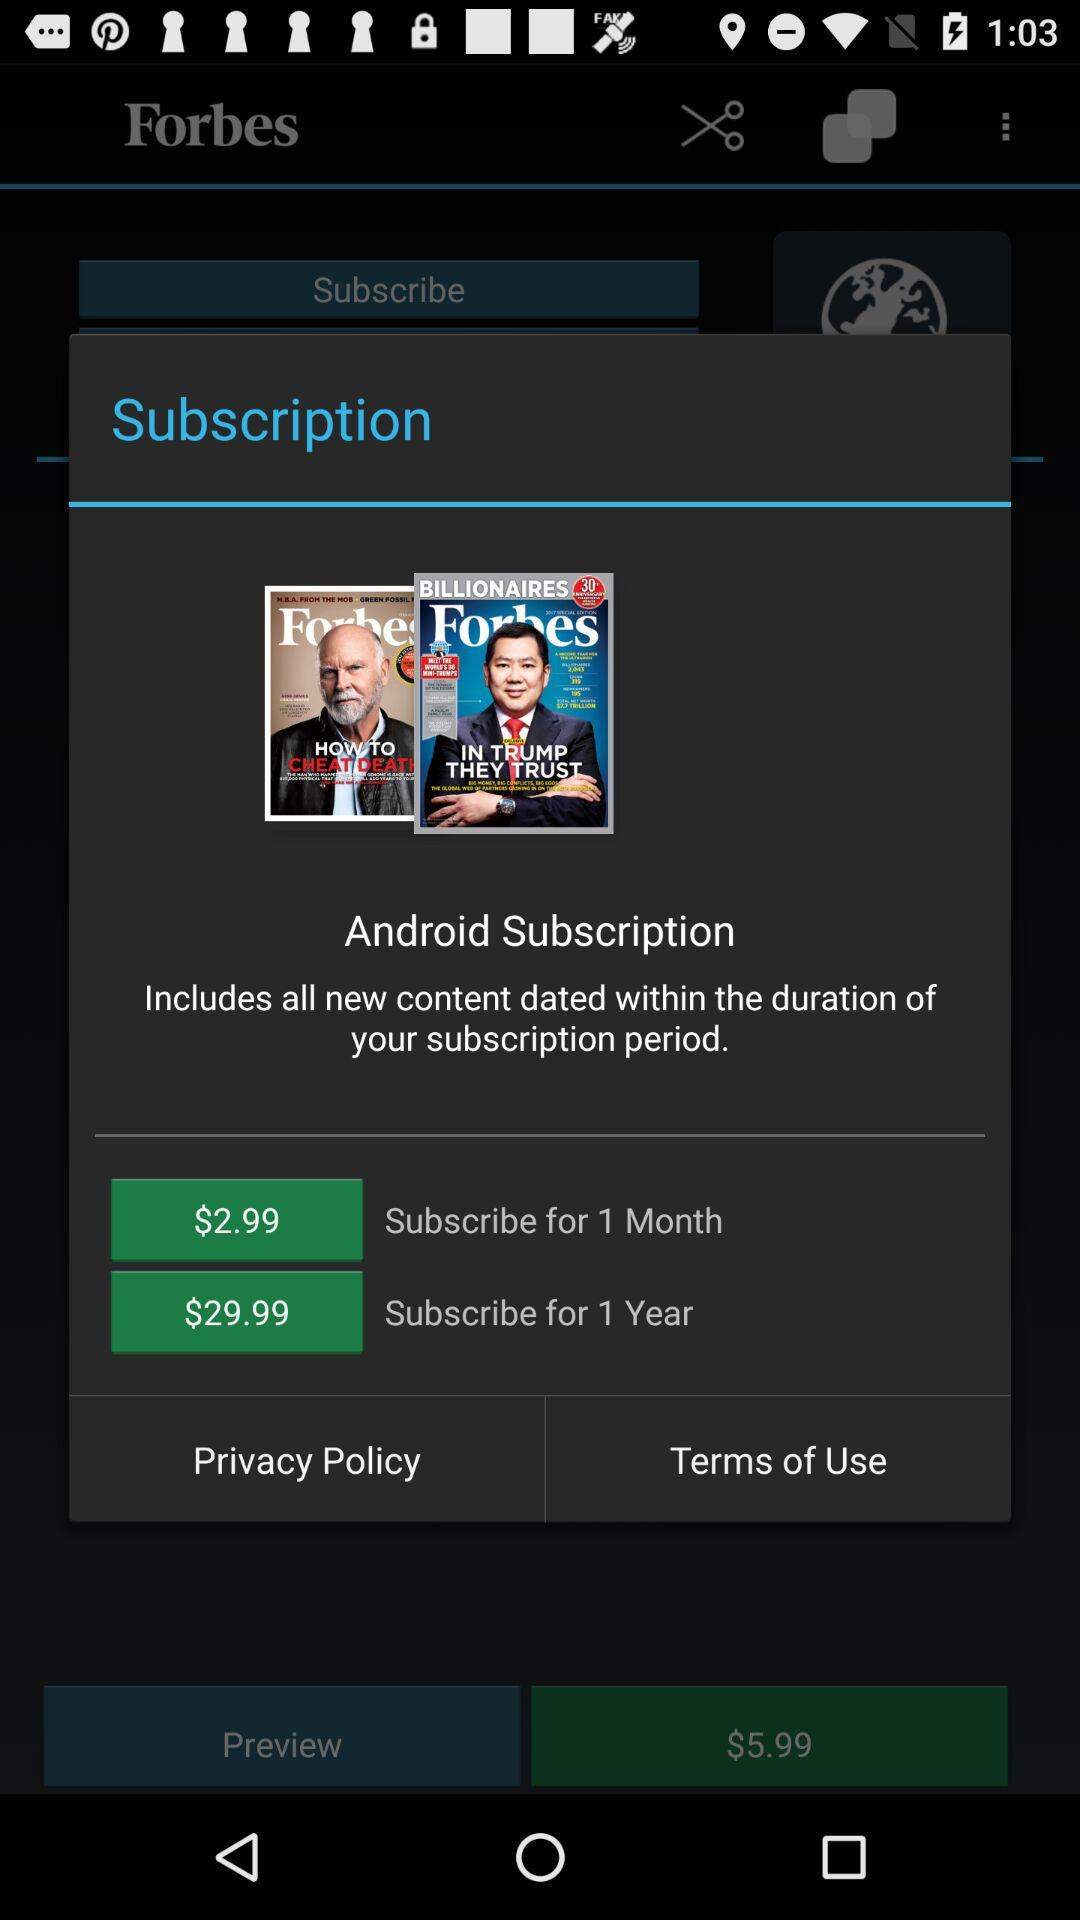What is the price of the one-year subscription? The price of the one-year subscription is $29.99. 